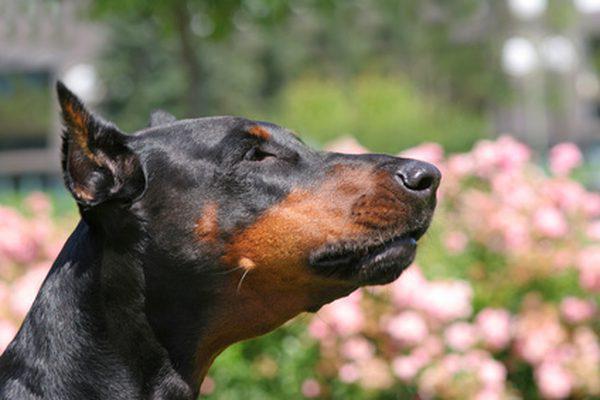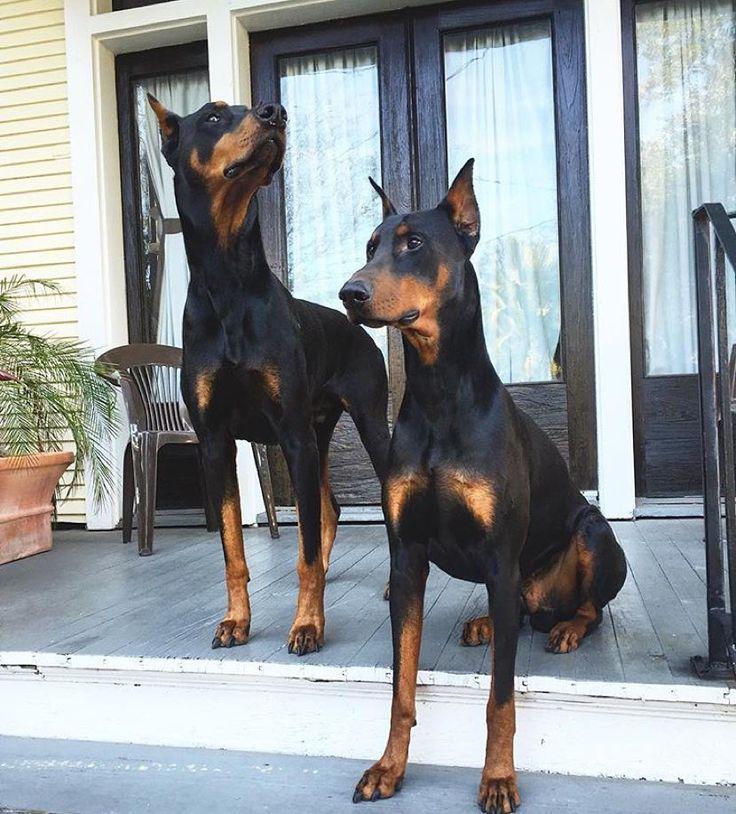The first image is the image on the left, the second image is the image on the right. For the images shown, is this caption "Both dogs are indoors." true? Answer yes or no. No. The first image is the image on the left, the second image is the image on the right. For the images displayed, is the sentence "The right image contains a black and brown dog inside on a wooden floor." factually correct? Answer yes or no. No. 